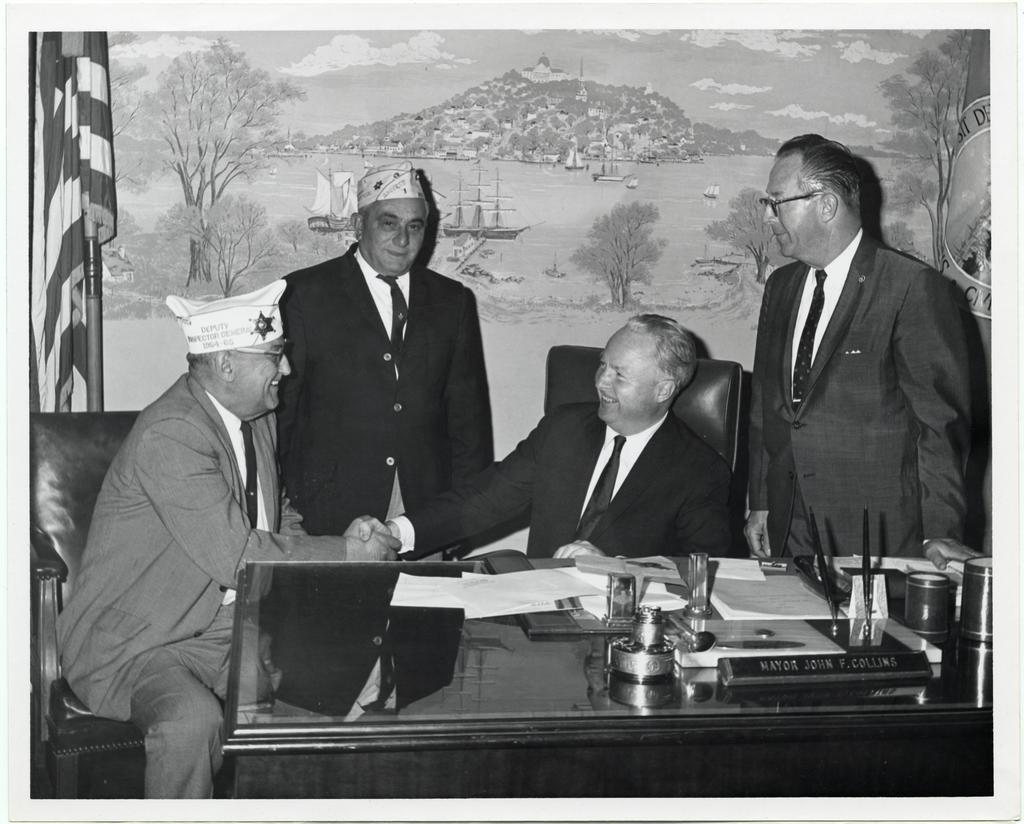In one or two sentences, can you explain what this image depicts? In this image there are 2 persons sitting in chair , another 2 persons standing beside them and in table there are name board ,paper, pen , and in back ground there is a wall paper, flag. 